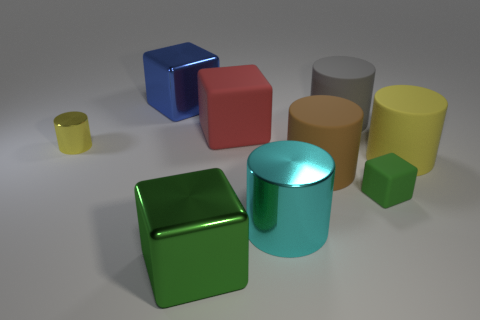Subtract 1 blocks. How many blocks are left? 3 Subtract all cyan cylinders. How many cylinders are left? 4 Subtract all purple cylinders. Subtract all yellow spheres. How many cylinders are left? 5 Subtract all cylinders. How many objects are left? 4 Subtract 1 red blocks. How many objects are left? 8 Subtract all big gray spheres. Subtract all large blue shiny things. How many objects are left? 8 Add 9 cyan objects. How many cyan objects are left? 10 Add 8 yellow matte spheres. How many yellow matte spheres exist? 8 